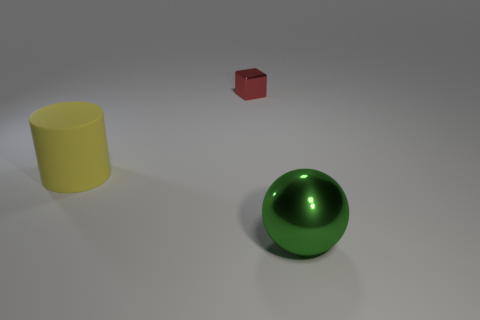Add 1 tiny metal objects. How many objects exist? 4 Subtract all balls. How many objects are left? 2 Subtract 0 yellow balls. How many objects are left? 3 Subtract all gray rubber things. Subtract all red blocks. How many objects are left? 2 Add 1 yellow matte things. How many yellow matte things are left? 2 Add 3 rubber objects. How many rubber objects exist? 4 